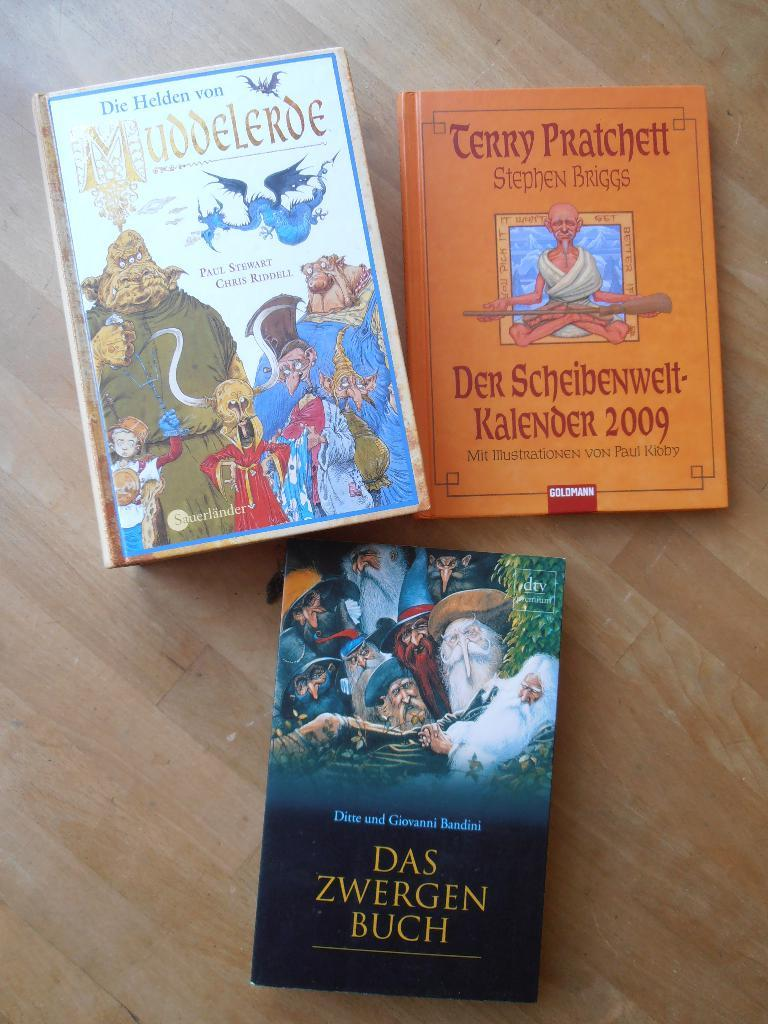<image>
Give a short and clear explanation of the subsequent image. A booked titled Das Zwergen Buch sits on a wooden floor with two other books 